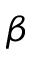<formula> <loc_0><loc_0><loc_500><loc_500>\beta</formula> 